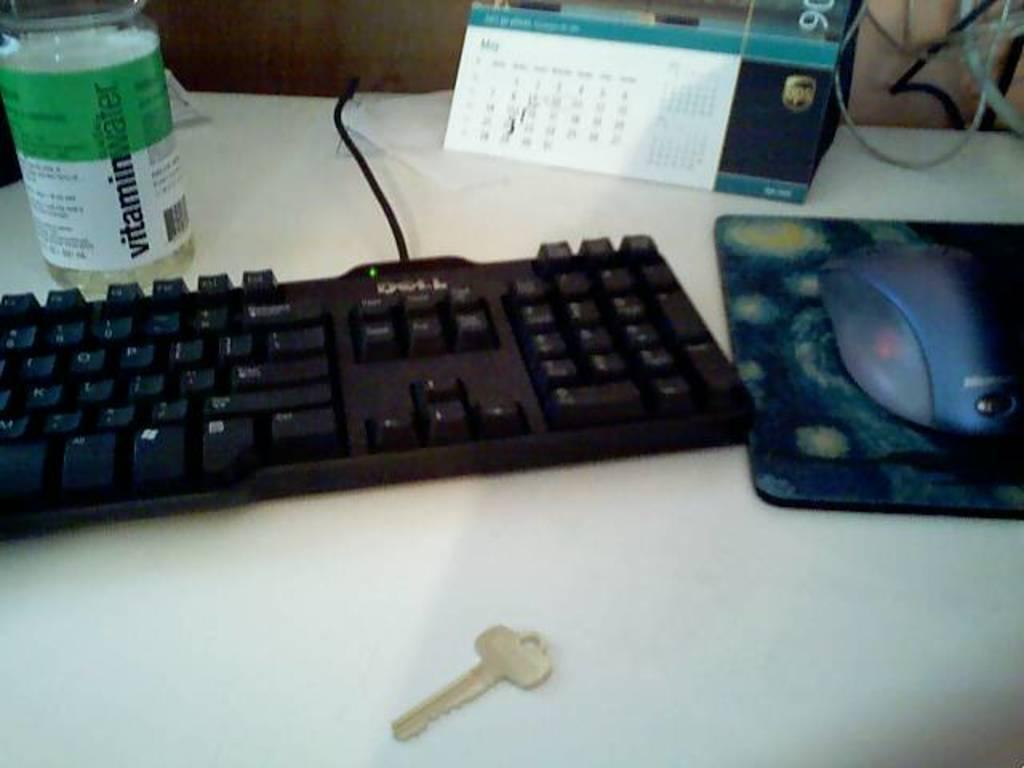<image>
Provide a brief description of the given image. A key is laying on a desk in front of a Dell keyboard. 